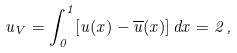<formula> <loc_0><loc_0><loc_500><loc_500>u _ { V } = \int _ { 0 } ^ { 1 } [ u ( x ) - { \overline { u } } ( x ) ] \, d x = 2 \, ,</formula> 